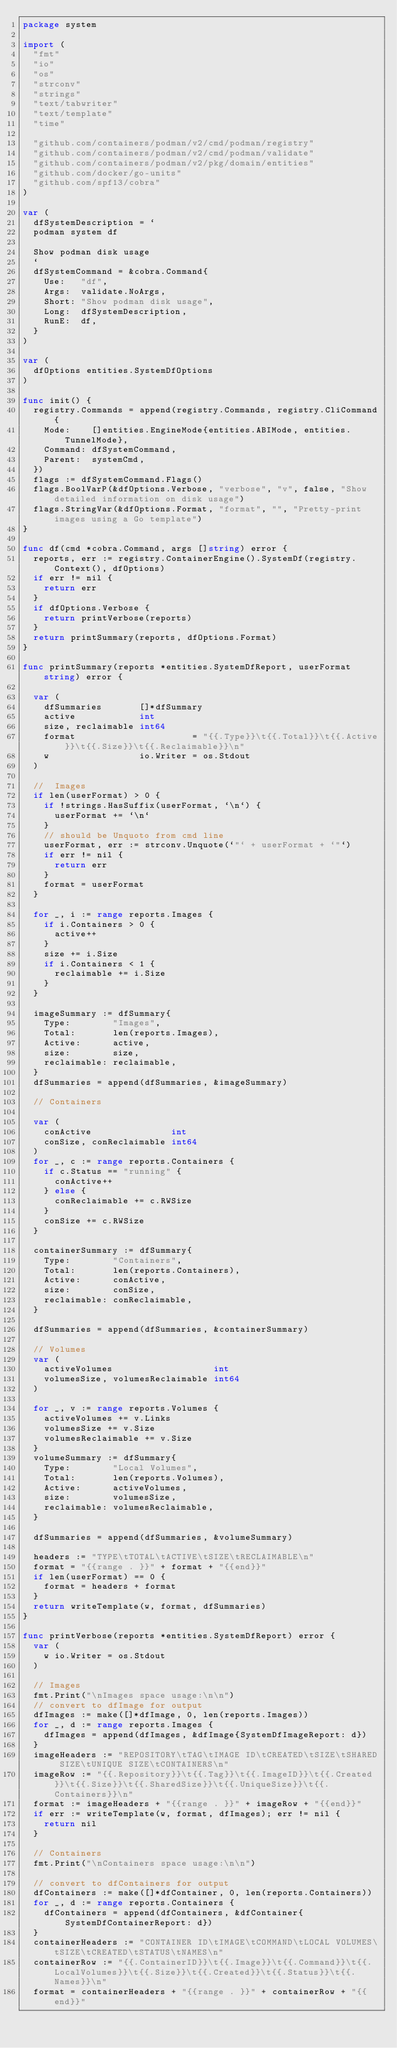Convert code to text. <code><loc_0><loc_0><loc_500><loc_500><_Go_>package system

import (
	"fmt"
	"io"
	"os"
	"strconv"
	"strings"
	"text/tabwriter"
	"text/template"
	"time"

	"github.com/containers/podman/v2/cmd/podman/registry"
	"github.com/containers/podman/v2/cmd/podman/validate"
	"github.com/containers/podman/v2/pkg/domain/entities"
	"github.com/docker/go-units"
	"github.com/spf13/cobra"
)

var (
	dfSystemDescription = `
	podman system df

	Show podman disk usage
	`
	dfSystemCommand = &cobra.Command{
		Use:   "df",
		Args:  validate.NoArgs,
		Short: "Show podman disk usage",
		Long:  dfSystemDescription,
		RunE:  df,
	}
)

var (
	dfOptions entities.SystemDfOptions
)

func init() {
	registry.Commands = append(registry.Commands, registry.CliCommand{
		Mode:    []entities.EngineMode{entities.ABIMode, entities.TunnelMode},
		Command: dfSystemCommand,
		Parent:  systemCmd,
	})
	flags := dfSystemCommand.Flags()
	flags.BoolVarP(&dfOptions.Verbose, "verbose", "v", false, "Show detailed information on disk usage")
	flags.StringVar(&dfOptions.Format, "format", "", "Pretty-print images using a Go template")
}

func df(cmd *cobra.Command, args []string) error {
	reports, err := registry.ContainerEngine().SystemDf(registry.Context(), dfOptions)
	if err != nil {
		return err
	}
	if dfOptions.Verbose {
		return printVerbose(reports)
	}
	return printSummary(reports, dfOptions.Format)
}

func printSummary(reports *entities.SystemDfReport, userFormat string) error {

	var (
		dfSummaries       []*dfSummary
		active            int
		size, reclaimable int64
		format                      = "{{.Type}}\t{{.Total}}\t{{.Active}}\t{{.Size}}\t{{.Reclaimable}}\n"
		w                 io.Writer = os.Stdout
	)

	//	Images
	if len(userFormat) > 0 {
		if !strings.HasSuffix(userFormat, `\n`) {
			userFormat += `\n`
		}
		// should be Unquoto from cmd line
		userFormat, err := strconv.Unquote(`"` + userFormat + `"`)
		if err != nil {
			return err
		}
		format = userFormat
	}

	for _, i := range reports.Images {
		if i.Containers > 0 {
			active++
		}
		size += i.Size
		if i.Containers < 1 {
			reclaimable += i.Size
		}
	}

	imageSummary := dfSummary{
		Type:        "Images",
		Total:       len(reports.Images),
		Active:      active,
		size:        size,
		reclaimable: reclaimable,
	}
	dfSummaries = append(dfSummaries, &imageSummary)

	// Containers

	var (
		conActive               int
		conSize, conReclaimable int64
	)
	for _, c := range reports.Containers {
		if c.Status == "running" {
			conActive++
		} else {
			conReclaimable += c.RWSize
		}
		conSize += c.RWSize
	}

	containerSummary := dfSummary{
		Type:        "Containers",
		Total:       len(reports.Containers),
		Active:      conActive,
		size:        conSize,
		reclaimable: conReclaimable,
	}

	dfSummaries = append(dfSummaries, &containerSummary)

	// Volumes
	var (
		activeVolumes                   int
		volumesSize, volumesReclaimable int64
	)

	for _, v := range reports.Volumes {
		activeVolumes += v.Links
		volumesSize += v.Size
		volumesReclaimable += v.Size
	}
	volumeSummary := dfSummary{
		Type:        "Local Volumes",
		Total:       len(reports.Volumes),
		Active:      activeVolumes,
		size:        volumesSize,
		reclaimable: volumesReclaimable,
	}

	dfSummaries = append(dfSummaries, &volumeSummary)

	headers := "TYPE\tTOTAL\tACTIVE\tSIZE\tRECLAIMABLE\n"
	format = "{{range . }}" + format + "{{end}}"
	if len(userFormat) == 0 {
		format = headers + format
	}
	return writeTemplate(w, format, dfSummaries)
}

func printVerbose(reports *entities.SystemDfReport) error {
	var (
		w io.Writer = os.Stdout
	)

	// Images
	fmt.Print("\nImages space usage:\n\n")
	// convert to dfImage for output
	dfImages := make([]*dfImage, 0, len(reports.Images))
	for _, d := range reports.Images {
		dfImages = append(dfImages, &dfImage{SystemDfImageReport: d})
	}
	imageHeaders := "REPOSITORY\tTAG\tIMAGE ID\tCREATED\tSIZE\tSHARED SIZE\tUNIQUE SIZE\tCONTAINERS\n"
	imageRow := "{{.Repository}}\t{{.Tag}}\t{{.ImageID}}\t{{.Created}}\t{{.Size}}\t{{.SharedSize}}\t{{.UniqueSize}}\t{{.Containers}}\n"
	format := imageHeaders + "{{range . }}" + imageRow + "{{end}}"
	if err := writeTemplate(w, format, dfImages); err != nil {
		return nil
	}

	// Containers
	fmt.Print("\nContainers space usage:\n\n")

	// convert to dfContainers for output
	dfContainers := make([]*dfContainer, 0, len(reports.Containers))
	for _, d := range reports.Containers {
		dfContainers = append(dfContainers, &dfContainer{SystemDfContainerReport: d})
	}
	containerHeaders := "CONTAINER ID\tIMAGE\tCOMMAND\tLOCAL VOLUMES\tSIZE\tCREATED\tSTATUS\tNAMES\n"
	containerRow := "{{.ContainerID}}\t{{.Image}}\t{{.Command}}\t{{.LocalVolumes}}\t{{.Size}}\t{{.Created}}\t{{.Status}}\t{{.Names}}\n"
	format = containerHeaders + "{{range . }}" + containerRow + "{{end}}"</code> 